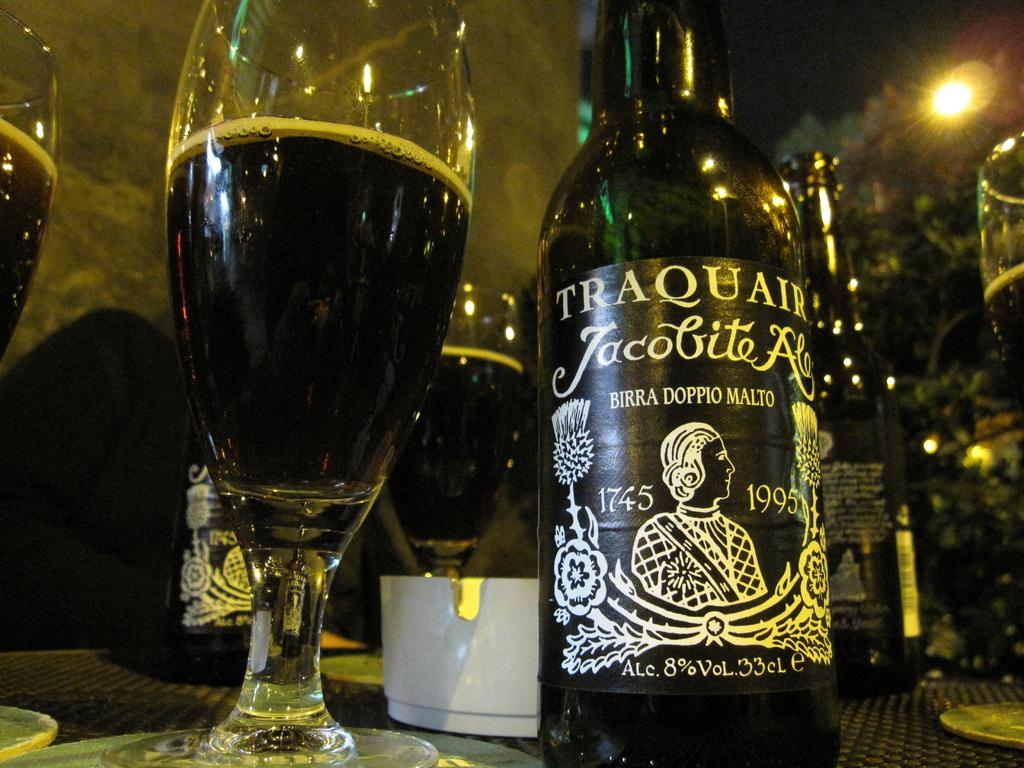<image>
Summarize the visual content of the image. A bottle of Traquair beer on an outdoors table. 